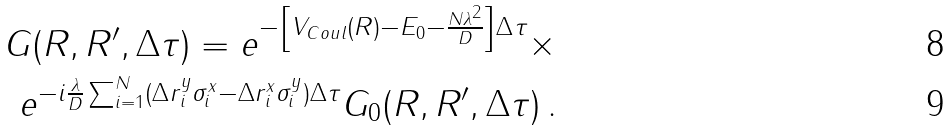<formula> <loc_0><loc_0><loc_500><loc_500>G ( R , R ^ { \prime } , \Delta \tau ) = e ^ { - \left [ V _ { C o u l } ( R ) - E _ { 0 } - \frac { N \lambda ^ { 2 } } { D } \right ] \Delta \tau } \times \\ e ^ { - i \frac { \lambda } { D } \sum ^ { N } _ { i = 1 } ( \Delta r _ { i } ^ { y } \sigma _ { i } ^ { x } - \Delta r _ { i } ^ { x } \sigma _ { i } ^ { y } ) \Delta \tau } G _ { 0 } ( R , R ^ { \prime } , \Delta \tau ) \, .</formula> 